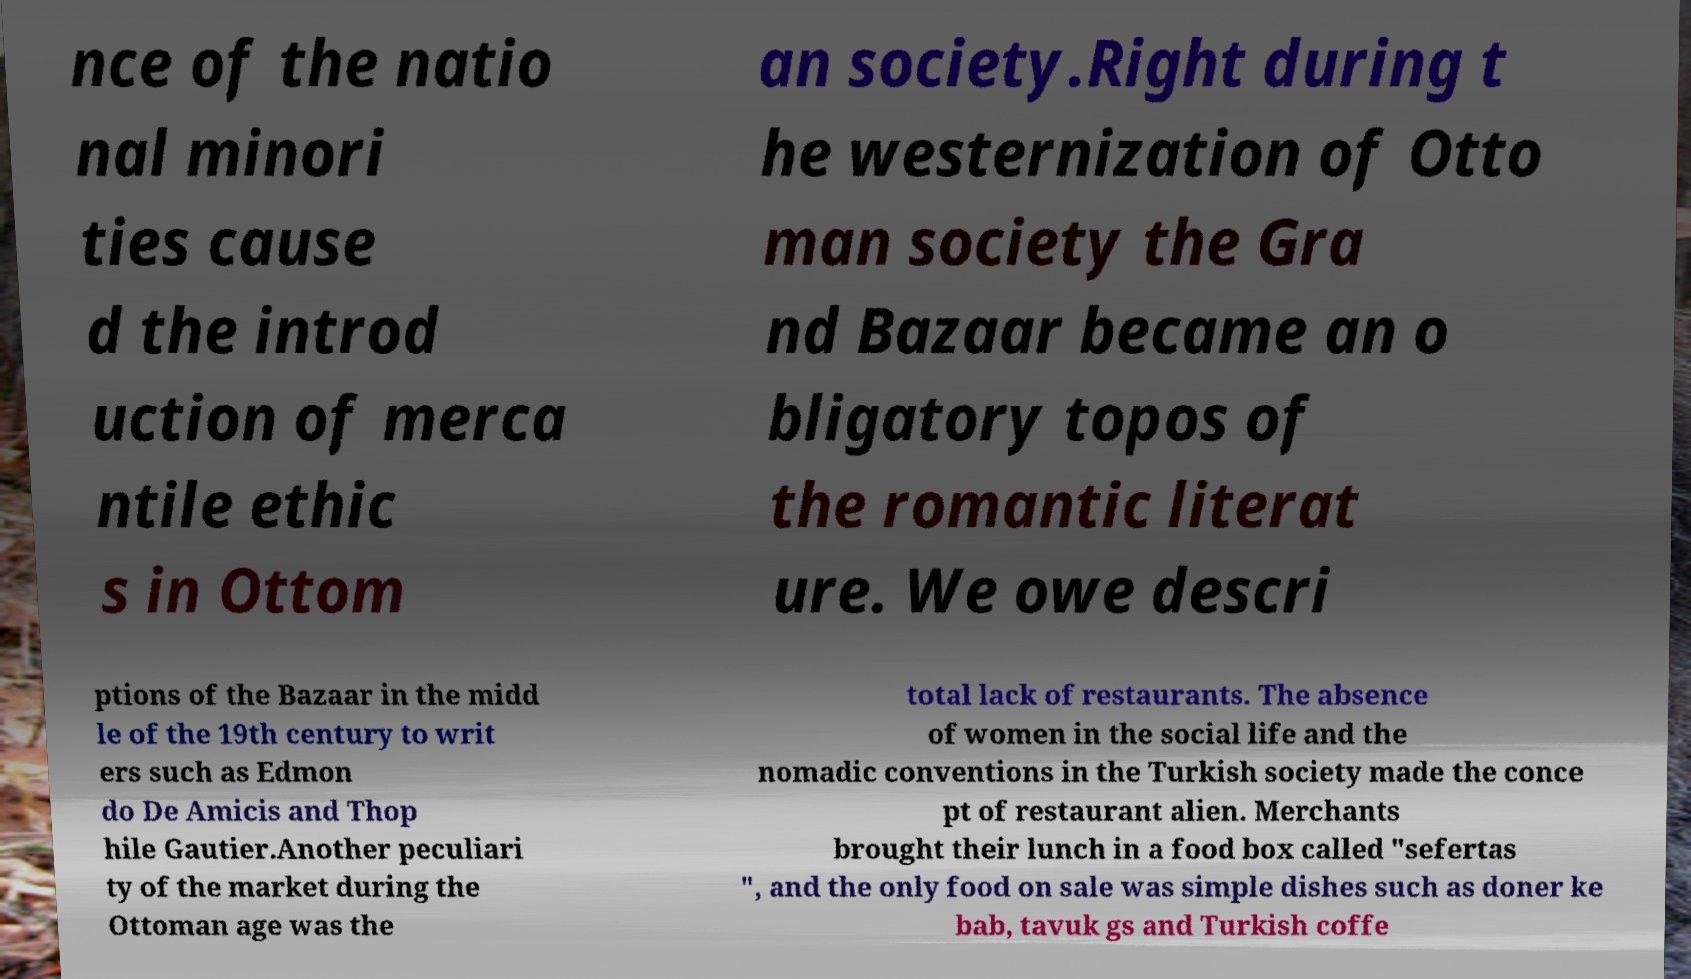There's text embedded in this image that I need extracted. Can you transcribe it verbatim? nce of the natio nal minori ties cause d the introd uction of merca ntile ethic s in Ottom an society.Right during t he westernization of Otto man society the Gra nd Bazaar became an o bligatory topos of the romantic literat ure. We owe descri ptions of the Bazaar in the midd le of the 19th century to writ ers such as Edmon do De Amicis and Thop hile Gautier.Another peculiari ty of the market during the Ottoman age was the total lack of restaurants. The absence of women in the social life and the nomadic conventions in the Turkish society made the conce pt of restaurant alien. Merchants brought their lunch in a food box called "sefertas ", and the only food on sale was simple dishes such as doner ke bab, tavuk gs and Turkish coffe 